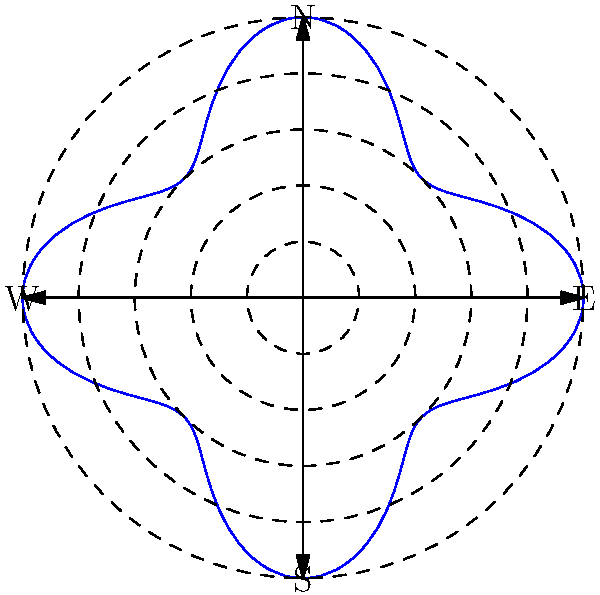The polar graph represents the wind speed and direction during an archery competition. The distance from the origin indicates wind speed (in m/s), and the angle represents the wind direction. What is the maximum wind speed, and in which direction does it occur? To solve this problem, we need to analyze the polar graph:

1. The graph shows a four-lobed rose curve, indicating four main wind directions.

2. The concentric dashed circles represent different wind speeds:
   - The innermost circle is at r = 0.5
   - The next circle is at r = 1.0
   - The third circle is at r = 1.5
   - The fourth circle is at r = 2.0
   - The outermost circle is at r = 2.5

3. The blue curve reaches its maximum distance from the origin where it touches the outermost circle.

4. This maximum occurs four times, corresponding to the four cardinal directions (N, E, S, W).

5. The maximum wind speed is therefore 2.5 m/s.

6. To determine the direction, we need to identify which cardinal direction(s) the curve touches the outermost circle.

7. Upon close inspection, we can see that the curve touches the outermost circle at the North (N) and South (S) points.

Therefore, the maximum wind speed is 2.5 m/s, occurring in both the North and South directions.
Answer: 2.5 m/s, North and South 